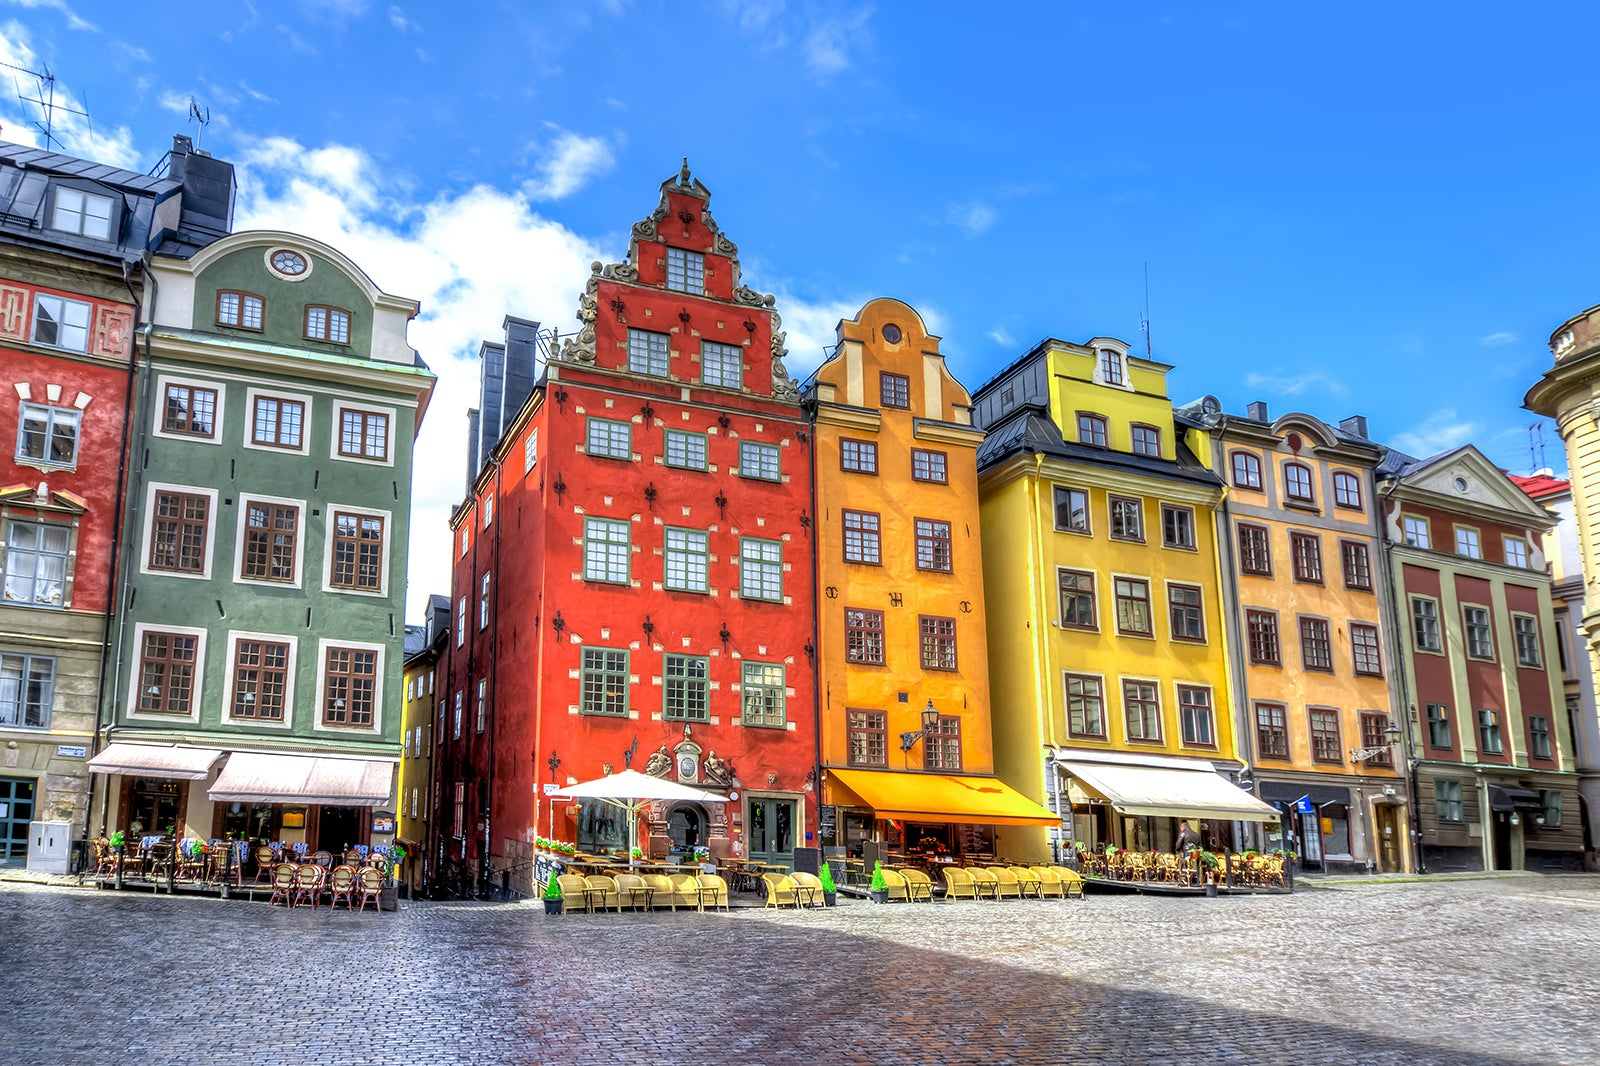Explain the visual content of the image in great detail. The image presents a stunning view of Gamla Stan, Stockholm's old town, renowned for its well-preserved medieval architecture. You see a vibrant street lined with buildings in vivid ochre, gold, red, and green hues, reflecting the area's historical richness. The architecture exhibits a mix of Baroque and Rococo styles, with ornate windows and facades, detailed cornices, and sculptural accents enriching the view. This scene is captured on a sunny day under a clear blue sky, which enhances the buildings' colors and casts soft shadows on the cobblestone pavement. Outdoor seating areas spread across the square suggest a lively social scene, likely buzzing with locals and tourists enjoying the area's cafes and restaurants. The historical significance coupled with the visual appeal makes this district a focal point for visitors seeking both aesthetic pleasure and a glimpse into Sweden's past. 